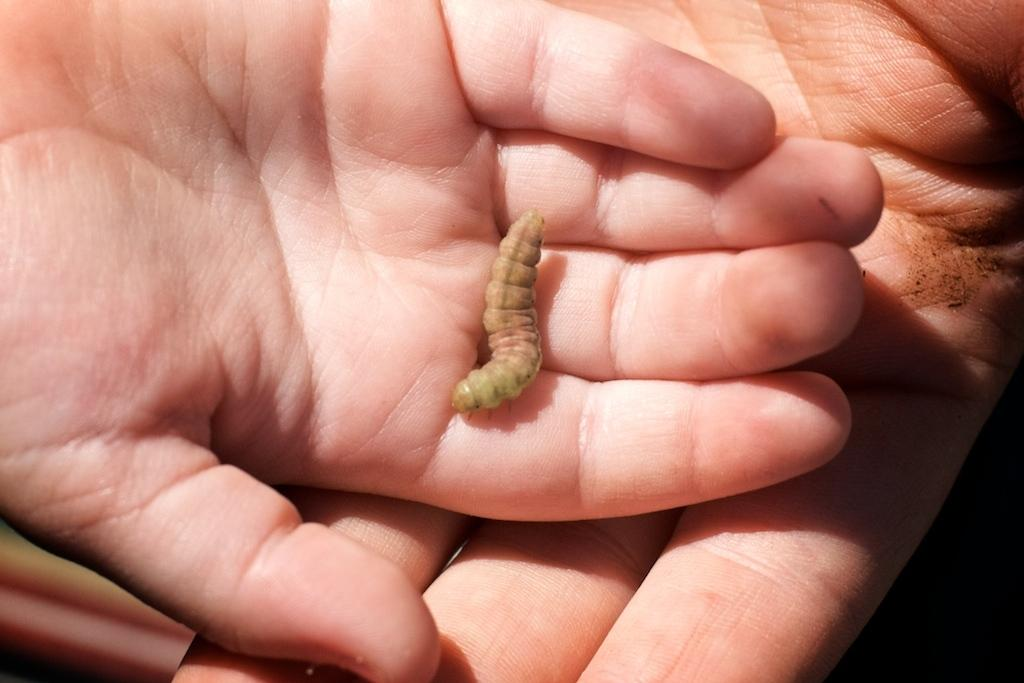What is the main subject of the image? The main subject of the image is a small worm. Where is the worm located in the image? The worm is in someone's hand. Can you describe the other hand in the image? There is a big hand beside the hand with the worm. What type of zebra can be seen balancing on the person's hand in the image? There is no zebra present in the image, and no one is balancing on the person's hand. 